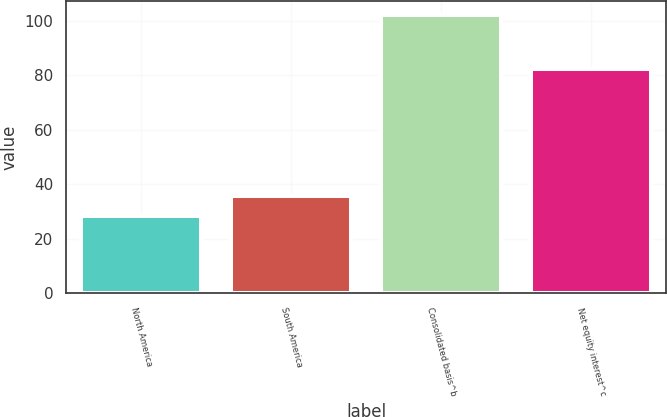Convert chart to OTSL. <chart><loc_0><loc_0><loc_500><loc_500><bar_chart><fcel>North America<fcel>South America<fcel>Consolidated basis^b<fcel>Net equity interest^c<nl><fcel>28.3<fcel>35.67<fcel>102<fcel>82.4<nl></chart> 